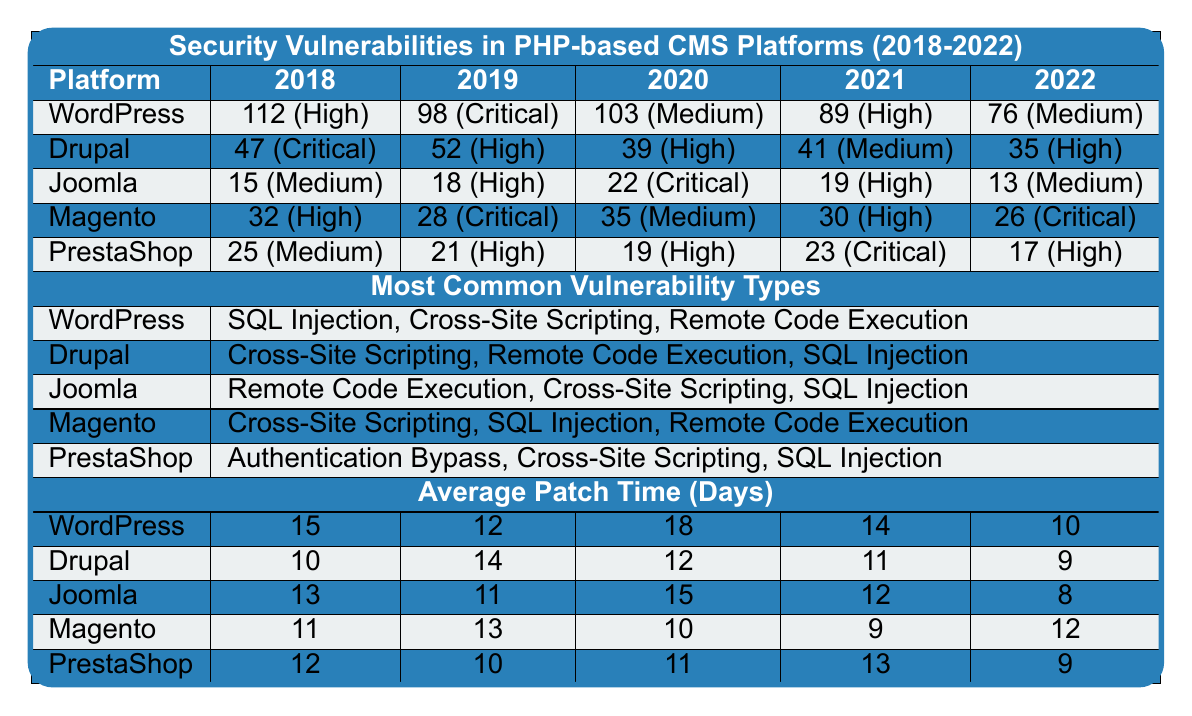What platform had the highest number of vulnerabilities in 2018? Looking at the table for the year 2018, WordPress has the highest number of vulnerabilities at 112, compared to other platforms' counts.
Answer: WordPress What is the average number of vulnerabilities for Joomla over the 5 years? To find the average, we sum up Joomla's vulnerabilities: 15 + 18 + 22 + 19 + 13 = 87. Then we divide by 5 (the number of years) giving us 87/5 = 17.4.
Answer: 17.4 Which platform had the least vulnerabilities in 2020? Checking the table for 2020, Joomla had the least number of vulnerabilities, with a total of 22 reported.
Answer: Joomla Is there a platform that consistently showed a downward trend in the number of vulnerabilities from 2018 to 2022? By examining the table, Joomla shows a consistent downward trend from 15 in 2018 to 13 in 2022, decreasing in each year.
Answer: Yes Which platform had the highest average patch time from 2018 to 2022? The average patch times for each platform are compared: WordPress (12.0), Drupal (11.2), Joomla (11.8), Magento (11.0), and PrestaShop (11.0). WordPress has the highest average patch time of 12.0 days.
Answer: WordPress Which type of vulnerability was the most common for Magento according to the table? The table indicates that for Magento, the most common types of vulnerabilities listed in 2022 were Cross-Site Scripting, SQL Injection, and Remote Code Execution.
Answer: Cross-Site Scripting In which year did Drupal experience the highest number of vulnerabilities? Reviewing the table, Drupal experienced the highest number of vulnerabilities in 2019 with a total of 52.
Answer: 2019 Did PrestaShop have any years with vulnerabilities classified as Critical? Referring to the table, PrestaShop had vulnerabilities classified as Critical in 2021, as shown by the entry for that year.
Answer: Yes What is the total number of vulnerabilities reported for WordPress over the entire 5 years? To find the total for WordPress, we add its vulnerabilities from each year: 112 + 98 + 103 + 89 + 76 = 478.
Answer: 478 Is the average patch time for Joomla less than that of PrestaShop? The average patch time for Joomla is 11.8 days, while for PrestaShop it is 11.0 days. Comparing these values, Joomla's average patch time is greater than PrestaShop's.
Answer: No 